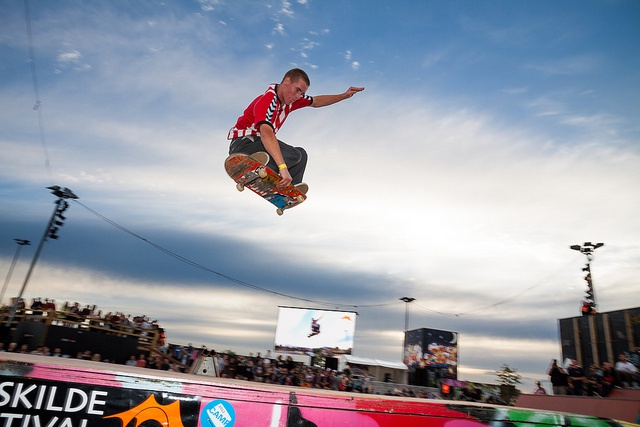Describe the objects in this image and their specific colors. I can see people in blue, black, maroon, gray, and darkgray tones, people in blue, black, brown, and maroon tones, skateboard in blue, maroon, gray, and brown tones, people in blue, black, gray, and maroon tones, and people in blue, black, gray, and maroon tones in this image. 